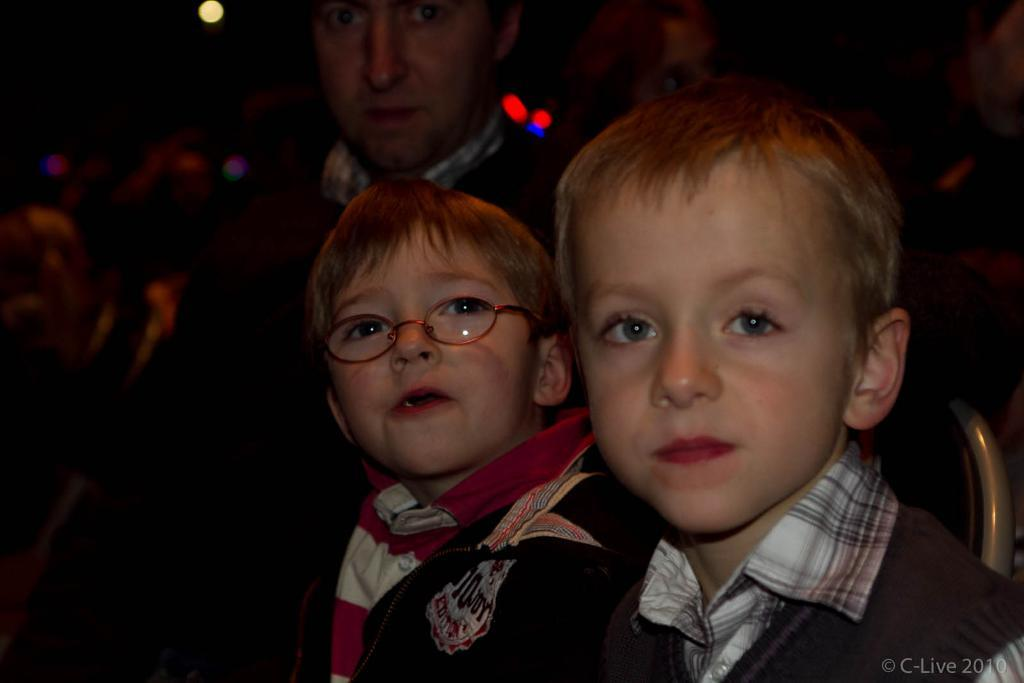How many people are in the image? There is a group of people in the image. Can you describe the position of the two boys in the foreground? Two boys are sitting on chairs in the foreground. What is the gender of the person in the image? There is a man in the image. What can be seen at the top of the image? There are lights visible at the top of the image. What is the base of the police car in the image? There is no police car present in the image. What is the rate of the fan in the image? There is no fan present in the image. 